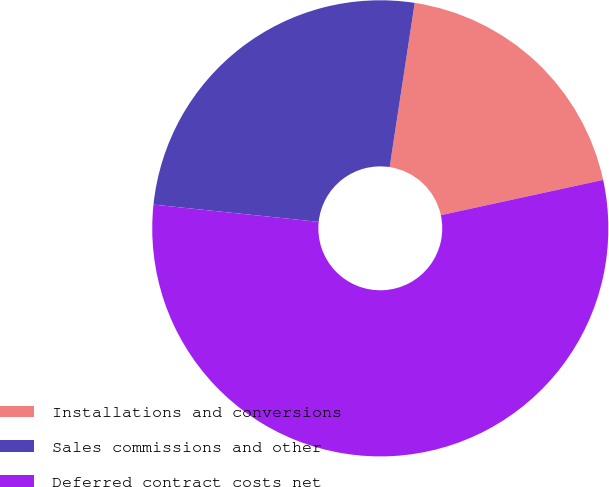<chart> <loc_0><loc_0><loc_500><loc_500><pie_chart><fcel>Installations and conversions<fcel>Sales commissions and other<fcel>Deferred contract costs net<nl><fcel>19.18%<fcel>25.75%<fcel>55.06%<nl></chart> 